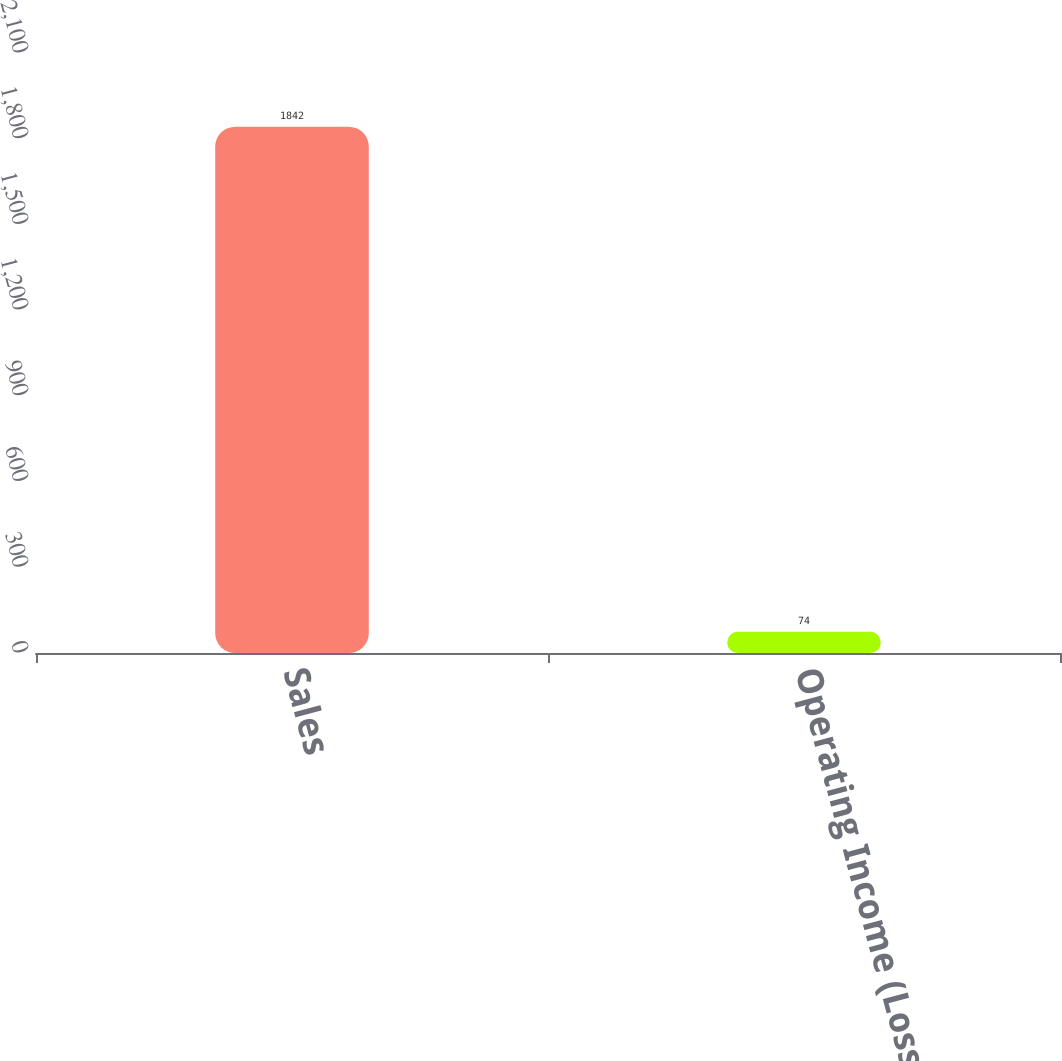<chart> <loc_0><loc_0><loc_500><loc_500><bar_chart><fcel>Sales<fcel>Operating Income (Loss)<nl><fcel>1842<fcel>74<nl></chart> 